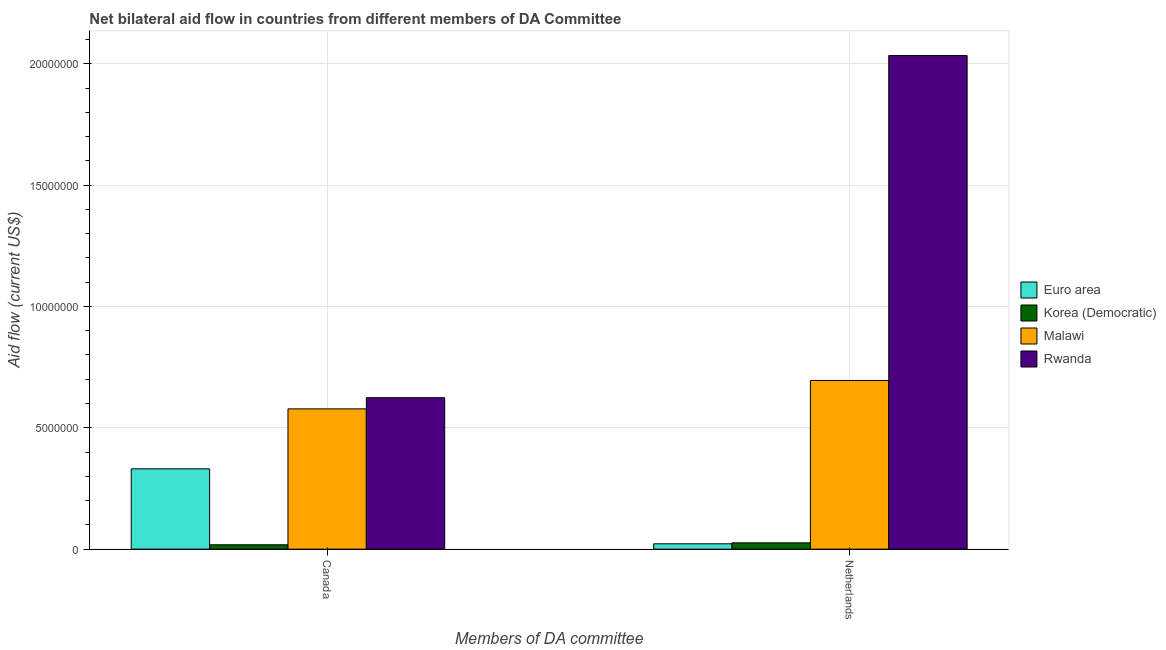How many groups of bars are there?
Make the answer very short. 2. What is the label of the 1st group of bars from the left?
Give a very brief answer. Canada. What is the amount of aid given by netherlands in Malawi?
Make the answer very short. 6.95e+06. Across all countries, what is the maximum amount of aid given by canada?
Ensure brevity in your answer.  6.24e+06. Across all countries, what is the minimum amount of aid given by netherlands?
Your answer should be very brief. 2.20e+05. In which country was the amount of aid given by canada maximum?
Provide a succinct answer. Rwanda. In which country was the amount of aid given by canada minimum?
Your answer should be very brief. Korea (Democratic). What is the total amount of aid given by netherlands in the graph?
Offer a terse response. 2.78e+07. What is the difference between the amount of aid given by canada in Malawi and that in Korea (Democratic)?
Your answer should be very brief. 5.60e+06. What is the difference between the amount of aid given by netherlands in Korea (Democratic) and the amount of aid given by canada in Rwanda?
Your answer should be very brief. -5.98e+06. What is the average amount of aid given by canada per country?
Your response must be concise. 3.88e+06. What is the difference between the amount of aid given by netherlands and amount of aid given by canada in Korea (Democratic)?
Your answer should be very brief. 8.00e+04. What is the ratio of the amount of aid given by canada in Euro area to that in Rwanda?
Ensure brevity in your answer.  0.53. Is the amount of aid given by netherlands in Rwanda less than that in Malawi?
Provide a succinct answer. No. In how many countries, is the amount of aid given by netherlands greater than the average amount of aid given by netherlands taken over all countries?
Provide a short and direct response. 2. What does the 1st bar from the left in Netherlands represents?
Ensure brevity in your answer.  Euro area. What does the 1st bar from the right in Netherlands represents?
Your answer should be very brief. Rwanda. Are the values on the major ticks of Y-axis written in scientific E-notation?
Offer a terse response. No. Does the graph contain grids?
Provide a short and direct response. Yes. What is the title of the graph?
Provide a succinct answer. Net bilateral aid flow in countries from different members of DA Committee. What is the label or title of the X-axis?
Make the answer very short. Members of DA committee. What is the Aid flow (current US$) of Euro area in Canada?
Your response must be concise. 3.31e+06. What is the Aid flow (current US$) of Malawi in Canada?
Give a very brief answer. 5.78e+06. What is the Aid flow (current US$) of Rwanda in Canada?
Keep it short and to the point. 6.24e+06. What is the Aid flow (current US$) of Malawi in Netherlands?
Offer a very short reply. 6.95e+06. What is the Aid flow (current US$) of Rwanda in Netherlands?
Ensure brevity in your answer.  2.03e+07. Across all Members of DA committee, what is the maximum Aid flow (current US$) in Euro area?
Offer a terse response. 3.31e+06. Across all Members of DA committee, what is the maximum Aid flow (current US$) of Malawi?
Provide a short and direct response. 6.95e+06. Across all Members of DA committee, what is the maximum Aid flow (current US$) in Rwanda?
Provide a short and direct response. 2.03e+07. Across all Members of DA committee, what is the minimum Aid flow (current US$) of Euro area?
Offer a very short reply. 2.20e+05. Across all Members of DA committee, what is the minimum Aid flow (current US$) in Malawi?
Offer a very short reply. 5.78e+06. Across all Members of DA committee, what is the minimum Aid flow (current US$) of Rwanda?
Your response must be concise. 6.24e+06. What is the total Aid flow (current US$) of Euro area in the graph?
Ensure brevity in your answer.  3.53e+06. What is the total Aid flow (current US$) in Malawi in the graph?
Your answer should be very brief. 1.27e+07. What is the total Aid flow (current US$) in Rwanda in the graph?
Offer a very short reply. 2.66e+07. What is the difference between the Aid flow (current US$) in Euro area in Canada and that in Netherlands?
Offer a terse response. 3.09e+06. What is the difference between the Aid flow (current US$) of Malawi in Canada and that in Netherlands?
Offer a very short reply. -1.17e+06. What is the difference between the Aid flow (current US$) of Rwanda in Canada and that in Netherlands?
Make the answer very short. -1.41e+07. What is the difference between the Aid flow (current US$) of Euro area in Canada and the Aid flow (current US$) of Korea (Democratic) in Netherlands?
Make the answer very short. 3.05e+06. What is the difference between the Aid flow (current US$) in Euro area in Canada and the Aid flow (current US$) in Malawi in Netherlands?
Keep it short and to the point. -3.64e+06. What is the difference between the Aid flow (current US$) of Euro area in Canada and the Aid flow (current US$) of Rwanda in Netherlands?
Give a very brief answer. -1.70e+07. What is the difference between the Aid flow (current US$) of Korea (Democratic) in Canada and the Aid flow (current US$) of Malawi in Netherlands?
Make the answer very short. -6.77e+06. What is the difference between the Aid flow (current US$) in Korea (Democratic) in Canada and the Aid flow (current US$) in Rwanda in Netherlands?
Your response must be concise. -2.02e+07. What is the difference between the Aid flow (current US$) in Malawi in Canada and the Aid flow (current US$) in Rwanda in Netherlands?
Give a very brief answer. -1.46e+07. What is the average Aid flow (current US$) of Euro area per Members of DA committee?
Provide a short and direct response. 1.76e+06. What is the average Aid flow (current US$) of Korea (Democratic) per Members of DA committee?
Provide a short and direct response. 2.20e+05. What is the average Aid flow (current US$) in Malawi per Members of DA committee?
Make the answer very short. 6.36e+06. What is the average Aid flow (current US$) of Rwanda per Members of DA committee?
Your answer should be compact. 1.33e+07. What is the difference between the Aid flow (current US$) of Euro area and Aid flow (current US$) of Korea (Democratic) in Canada?
Your answer should be compact. 3.13e+06. What is the difference between the Aid flow (current US$) in Euro area and Aid flow (current US$) in Malawi in Canada?
Offer a very short reply. -2.47e+06. What is the difference between the Aid flow (current US$) in Euro area and Aid flow (current US$) in Rwanda in Canada?
Provide a succinct answer. -2.93e+06. What is the difference between the Aid flow (current US$) in Korea (Democratic) and Aid flow (current US$) in Malawi in Canada?
Your response must be concise. -5.60e+06. What is the difference between the Aid flow (current US$) of Korea (Democratic) and Aid flow (current US$) of Rwanda in Canada?
Offer a very short reply. -6.06e+06. What is the difference between the Aid flow (current US$) of Malawi and Aid flow (current US$) of Rwanda in Canada?
Offer a terse response. -4.60e+05. What is the difference between the Aid flow (current US$) of Euro area and Aid flow (current US$) of Korea (Democratic) in Netherlands?
Provide a succinct answer. -4.00e+04. What is the difference between the Aid flow (current US$) in Euro area and Aid flow (current US$) in Malawi in Netherlands?
Offer a very short reply. -6.73e+06. What is the difference between the Aid flow (current US$) of Euro area and Aid flow (current US$) of Rwanda in Netherlands?
Ensure brevity in your answer.  -2.01e+07. What is the difference between the Aid flow (current US$) in Korea (Democratic) and Aid flow (current US$) in Malawi in Netherlands?
Your answer should be very brief. -6.69e+06. What is the difference between the Aid flow (current US$) in Korea (Democratic) and Aid flow (current US$) in Rwanda in Netherlands?
Provide a short and direct response. -2.01e+07. What is the difference between the Aid flow (current US$) in Malawi and Aid flow (current US$) in Rwanda in Netherlands?
Keep it short and to the point. -1.34e+07. What is the ratio of the Aid flow (current US$) of Euro area in Canada to that in Netherlands?
Your response must be concise. 15.05. What is the ratio of the Aid flow (current US$) of Korea (Democratic) in Canada to that in Netherlands?
Give a very brief answer. 0.69. What is the ratio of the Aid flow (current US$) in Malawi in Canada to that in Netherlands?
Keep it short and to the point. 0.83. What is the ratio of the Aid flow (current US$) of Rwanda in Canada to that in Netherlands?
Give a very brief answer. 0.31. What is the difference between the highest and the second highest Aid flow (current US$) in Euro area?
Make the answer very short. 3.09e+06. What is the difference between the highest and the second highest Aid flow (current US$) in Malawi?
Give a very brief answer. 1.17e+06. What is the difference between the highest and the second highest Aid flow (current US$) of Rwanda?
Your answer should be very brief. 1.41e+07. What is the difference between the highest and the lowest Aid flow (current US$) in Euro area?
Your answer should be very brief. 3.09e+06. What is the difference between the highest and the lowest Aid flow (current US$) in Malawi?
Keep it short and to the point. 1.17e+06. What is the difference between the highest and the lowest Aid flow (current US$) in Rwanda?
Your response must be concise. 1.41e+07. 